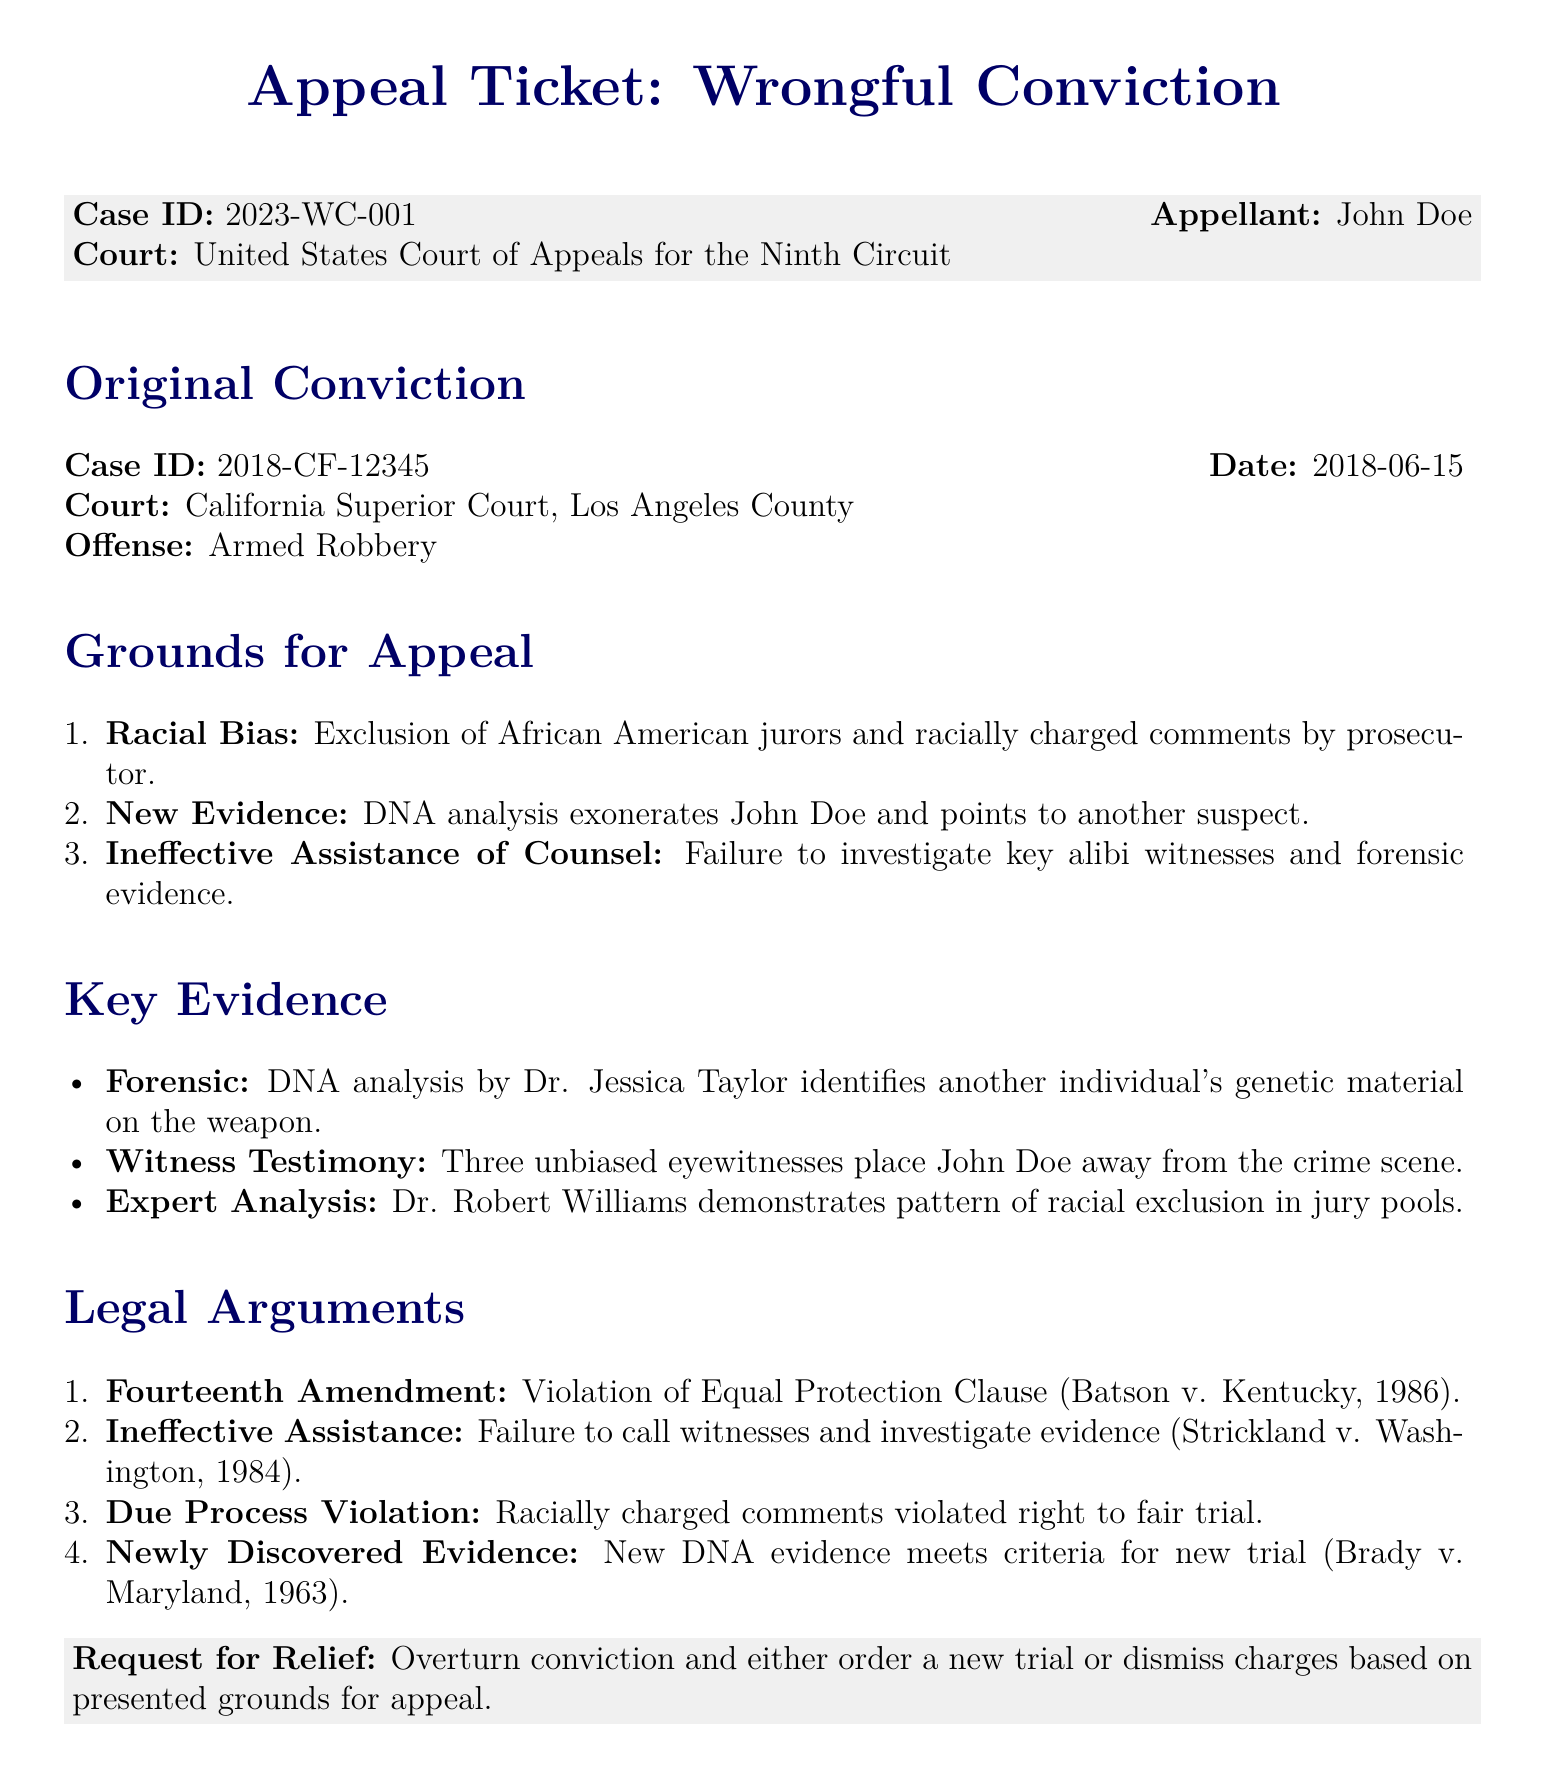What is the case ID for the appeal? The case ID is listed at the top of the document under the appeal section.
Answer: 2023-WC-001 Who is the appellant? The appellant's name is provided in the document as the individual bringing the appeal.
Answer: John Doe What offense was John Doe originally convicted of? The offense is specified in the original conviction section of the document.
Answer: Armed Robbery What is one of the grounds for appeal related to jury selection? The document discusses issues regarding racial bias affecting the jury.
Answer: Racial Bias How many eyewitnesses placed John Doe away from the crime scene? The number of unbiased eyewitnesses is stated in the key evidence section.
Answer: Three What constitutional amendment is cited for the violation of the Equal Protection Clause? The legal argument section references a specific amendment related to the appeal.
Answer: Fourteenth Amendment Who conducted the DNA analysis that exonerates John Doe? The document mentions an expert responsible for the forensic analysis.
Answer: Dr. Jessica Taylor What date was John Doe's original conviction? The date of conviction is specified in the original conviction section of the document.
Answer: 2018-06-15 What type of relief is being requested in the appeal? The request for relief is outlined at the end of the document.
Answer: Overturn conviction 